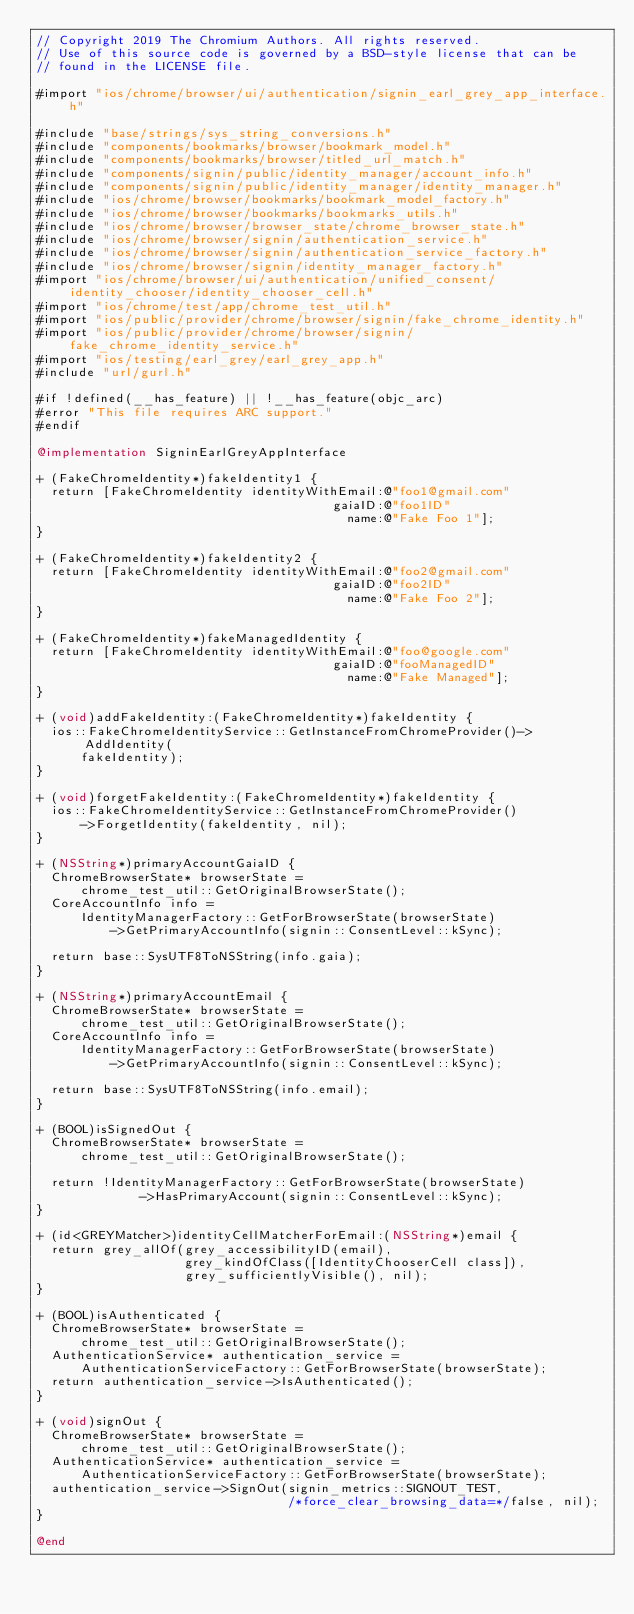Convert code to text. <code><loc_0><loc_0><loc_500><loc_500><_ObjectiveC_>// Copyright 2019 The Chromium Authors. All rights reserved.
// Use of this source code is governed by a BSD-style license that can be
// found in the LICENSE file.

#import "ios/chrome/browser/ui/authentication/signin_earl_grey_app_interface.h"

#include "base/strings/sys_string_conversions.h"
#include "components/bookmarks/browser/bookmark_model.h"
#include "components/bookmarks/browser/titled_url_match.h"
#include "components/signin/public/identity_manager/account_info.h"
#include "components/signin/public/identity_manager/identity_manager.h"
#include "ios/chrome/browser/bookmarks/bookmark_model_factory.h"
#include "ios/chrome/browser/bookmarks/bookmarks_utils.h"
#include "ios/chrome/browser/browser_state/chrome_browser_state.h"
#include "ios/chrome/browser/signin/authentication_service.h"
#include "ios/chrome/browser/signin/authentication_service_factory.h"
#include "ios/chrome/browser/signin/identity_manager_factory.h"
#import "ios/chrome/browser/ui/authentication/unified_consent/identity_chooser/identity_chooser_cell.h"
#import "ios/chrome/test/app/chrome_test_util.h"
#import "ios/public/provider/chrome/browser/signin/fake_chrome_identity.h"
#import "ios/public/provider/chrome/browser/signin/fake_chrome_identity_service.h"
#import "ios/testing/earl_grey/earl_grey_app.h"
#include "url/gurl.h"

#if !defined(__has_feature) || !__has_feature(objc_arc)
#error "This file requires ARC support."
#endif

@implementation SigninEarlGreyAppInterface

+ (FakeChromeIdentity*)fakeIdentity1 {
  return [FakeChromeIdentity identityWithEmail:@"foo1@gmail.com"
                                        gaiaID:@"foo1ID"
                                          name:@"Fake Foo 1"];
}

+ (FakeChromeIdentity*)fakeIdentity2 {
  return [FakeChromeIdentity identityWithEmail:@"foo2@gmail.com"
                                        gaiaID:@"foo2ID"
                                          name:@"Fake Foo 2"];
}

+ (FakeChromeIdentity*)fakeManagedIdentity {
  return [FakeChromeIdentity identityWithEmail:@"foo@google.com"
                                        gaiaID:@"fooManagedID"
                                          name:@"Fake Managed"];
}

+ (void)addFakeIdentity:(FakeChromeIdentity*)fakeIdentity {
  ios::FakeChromeIdentityService::GetInstanceFromChromeProvider()->AddIdentity(
      fakeIdentity);
}

+ (void)forgetFakeIdentity:(FakeChromeIdentity*)fakeIdentity {
  ios::FakeChromeIdentityService::GetInstanceFromChromeProvider()
      ->ForgetIdentity(fakeIdentity, nil);
}

+ (NSString*)primaryAccountGaiaID {
  ChromeBrowserState* browserState =
      chrome_test_util::GetOriginalBrowserState();
  CoreAccountInfo info =
      IdentityManagerFactory::GetForBrowserState(browserState)
          ->GetPrimaryAccountInfo(signin::ConsentLevel::kSync);

  return base::SysUTF8ToNSString(info.gaia);
}

+ (NSString*)primaryAccountEmail {
  ChromeBrowserState* browserState =
      chrome_test_util::GetOriginalBrowserState();
  CoreAccountInfo info =
      IdentityManagerFactory::GetForBrowserState(browserState)
          ->GetPrimaryAccountInfo(signin::ConsentLevel::kSync);

  return base::SysUTF8ToNSString(info.email);
}

+ (BOOL)isSignedOut {
  ChromeBrowserState* browserState =
      chrome_test_util::GetOriginalBrowserState();

  return !IdentityManagerFactory::GetForBrowserState(browserState)
              ->HasPrimaryAccount(signin::ConsentLevel::kSync);
}

+ (id<GREYMatcher>)identityCellMatcherForEmail:(NSString*)email {
  return grey_allOf(grey_accessibilityID(email),
                    grey_kindOfClass([IdentityChooserCell class]),
                    grey_sufficientlyVisible(), nil);
}

+ (BOOL)isAuthenticated {
  ChromeBrowserState* browserState =
      chrome_test_util::GetOriginalBrowserState();
  AuthenticationService* authentication_service =
      AuthenticationServiceFactory::GetForBrowserState(browserState);
  return authentication_service->IsAuthenticated();
}

+ (void)signOut {
  ChromeBrowserState* browserState =
      chrome_test_util::GetOriginalBrowserState();
  AuthenticationService* authentication_service =
      AuthenticationServiceFactory::GetForBrowserState(browserState);
  authentication_service->SignOut(signin_metrics::SIGNOUT_TEST,
                                  /*force_clear_browsing_data=*/false, nil);
}

@end
</code> 